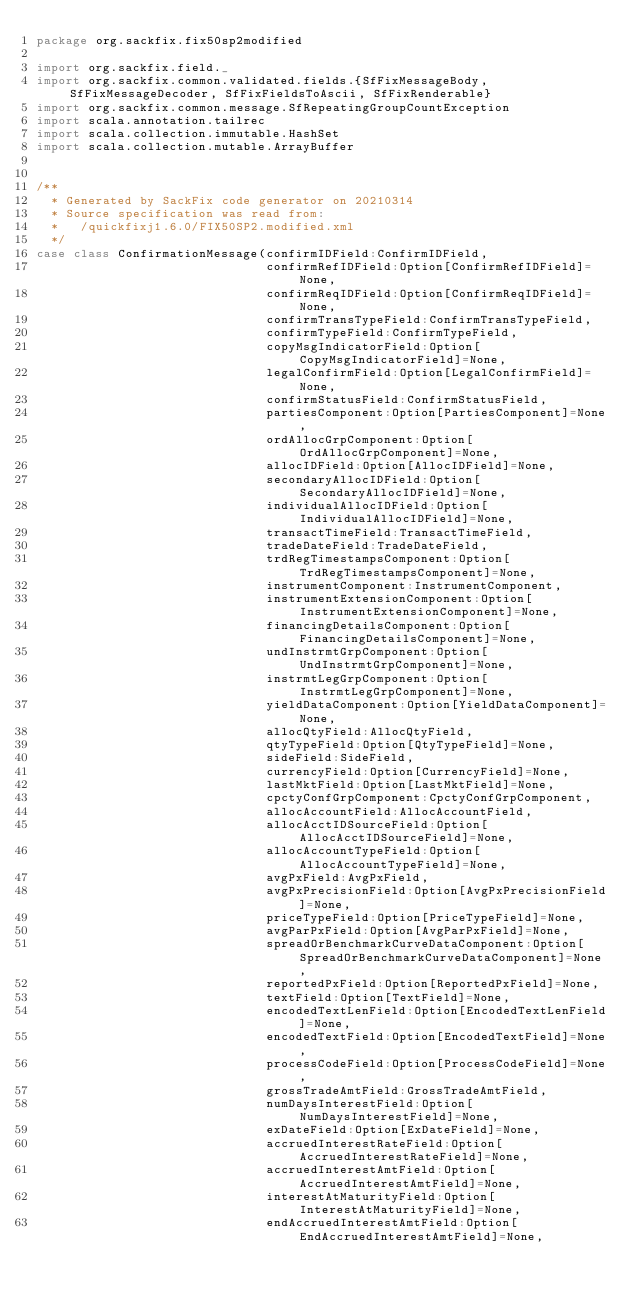Convert code to text. <code><loc_0><loc_0><loc_500><loc_500><_Scala_>package org.sackfix.fix50sp2modified

import org.sackfix.field._
import org.sackfix.common.validated.fields.{SfFixMessageBody, SfFixMessageDecoder, SfFixFieldsToAscii, SfFixRenderable}
import org.sackfix.common.message.SfRepeatingGroupCountException
import scala.annotation.tailrec
import scala.collection.immutable.HashSet
import scala.collection.mutable.ArrayBuffer


/**
  * Generated by SackFix code generator on 20210314
  * Source specification was read from:
  *   /quickfixj1.6.0/FIX50SP2.modified.xml
  */
case class ConfirmationMessage(confirmIDField:ConfirmIDField,
                               confirmRefIDField:Option[ConfirmRefIDField]=None,
                               confirmReqIDField:Option[ConfirmReqIDField]=None,
                               confirmTransTypeField:ConfirmTransTypeField,
                               confirmTypeField:ConfirmTypeField,
                               copyMsgIndicatorField:Option[CopyMsgIndicatorField]=None,
                               legalConfirmField:Option[LegalConfirmField]=None,
                               confirmStatusField:ConfirmStatusField,
                               partiesComponent:Option[PartiesComponent]=None,
                               ordAllocGrpComponent:Option[OrdAllocGrpComponent]=None,
                               allocIDField:Option[AllocIDField]=None,
                               secondaryAllocIDField:Option[SecondaryAllocIDField]=None,
                               individualAllocIDField:Option[IndividualAllocIDField]=None,
                               transactTimeField:TransactTimeField,
                               tradeDateField:TradeDateField,
                               trdRegTimestampsComponent:Option[TrdRegTimestampsComponent]=None,
                               instrumentComponent:InstrumentComponent,
                               instrumentExtensionComponent:Option[InstrumentExtensionComponent]=None,
                               financingDetailsComponent:Option[FinancingDetailsComponent]=None,
                               undInstrmtGrpComponent:Option[UndInstrmtGrpComponent]=None,
                               instrmtLegGrpComponent:Option[InstrmtLegGrpComponent]=None,
                               yieldDataComponent:Option[YieldDataComponent]=None,
                               allocQtyField:AllocQtyField,
                               qtyTypeField:Option[QtyTypeField]=None,
                               sideField:SideField,
                               currencyField:Option[CurrencyField]=None,
                               lastMktField:Option[LastMktField]=None,
                               cpctyConfGrpComponent:CpctyConfGrpComponent,
                               allocAccountField:AllocAccountField,
                               allocAcctIDSourceField:Option[AllocAcctIDSourceField]=None,
                               allocAccountTypeField:Option[AllocAccountTypeField]=None,
                               avgPxField:AvgPxField,
                               avgPxPrecisionField:Option[AvgPxPrecisionField]=None,
                               priceTypeField:Option[PriceTypeField]=None,
                               avgParPxField:Option[AvgParPxField]=None,
                               spreadOrBenchmarkCurveDataComponent:Option[SpreadOrBenchmarkCurveDataComponent]=None,
                               reportedPxField:Option[ReportedPxField]=None,
                               textField:Option[TextField]=None,
                               encodedTextLenField:Option[EncodedTextLenField]=None,
                               encodedTextField:Option[EncodedTextField]=None,
                               processCodeField:Option[ProcessCodeField]=None,
                               grossTradeAmtField:GrossTradeAmtField,
                               numDaysInterestField:Option[NumDaysInterestField]=None,
                               exDateField:Option[ExDateField]=None,
                               accruedInterestRateField:Option[AccruedInterestRateField]=None,
                               accruedInterestAmtField:Option[AccruedInterestAmtField]=None,
                               interestAtMaturityField:Option[InterestAtMaturityField]=None,
                               endAccruedInterestAmtField:Option[EndAccruedInterestAmtField]=None,</code> 